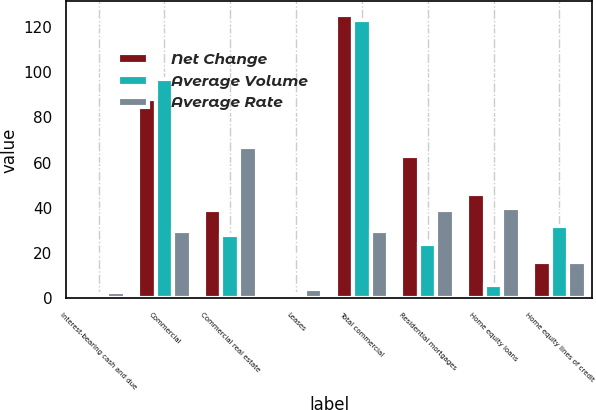<chart> <loc_0><loc_0><loc_500><loc_500><stacked_bar_chart><ecel><fcel>Interest-bearing cash and due<fcel>Commercial<fcel>Commercial real estate<fcel>Leases<fcel>Total commercial<fcel>Residential mortgages<fcel>Home equity loans<fcel>Home equity lines of credit<nl><fcel>Net Change<fcel>1<fcel>88<fcel>39<fcel>2<fcel>125<fcel>63<fcel>46<fcel>16<nl><fcel>Average Volume<fcel>2<fcel>97<fcel>28<fcel>2<fcel>123<fcel>24<fcel>6<fcel>32<nl><fcel>Average Rate<fcel>3<fcel>30<fcel>67<fcel>4<fcel>30<fcel>39<fcel>40<fcel>16<nl></chart> 